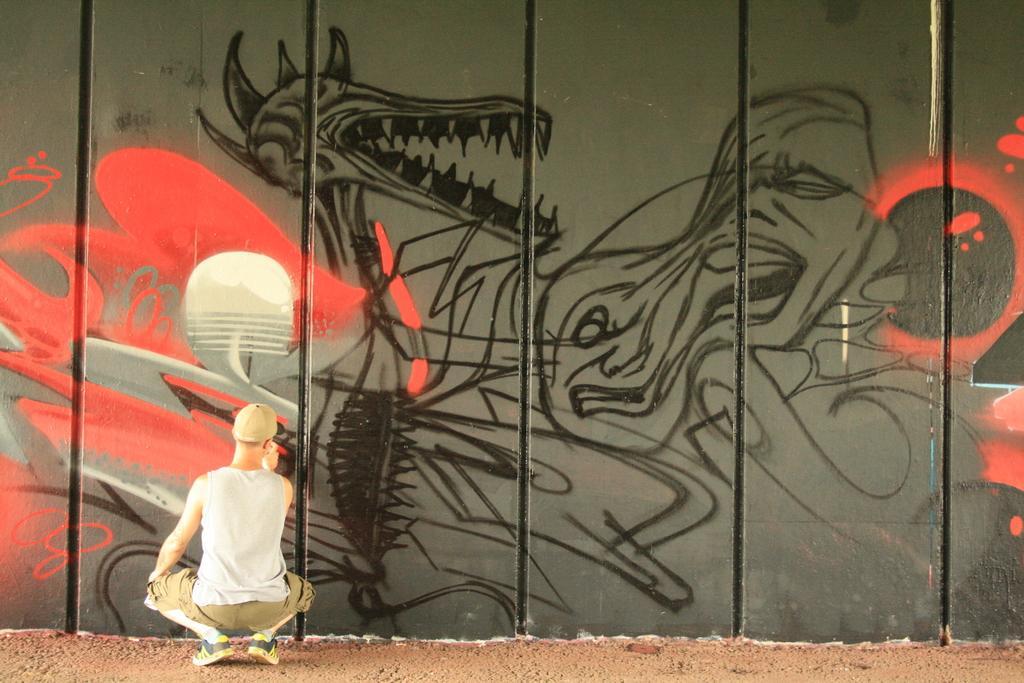Could you give a brief overview of what you see in this image? This picture seems to be clicked outside. On the left there is a person wearing white color t-shirt, squatting on the ground and seems to be drawing something on the wall. In the background there is a wall on which we can see the drawing of some creatures. 